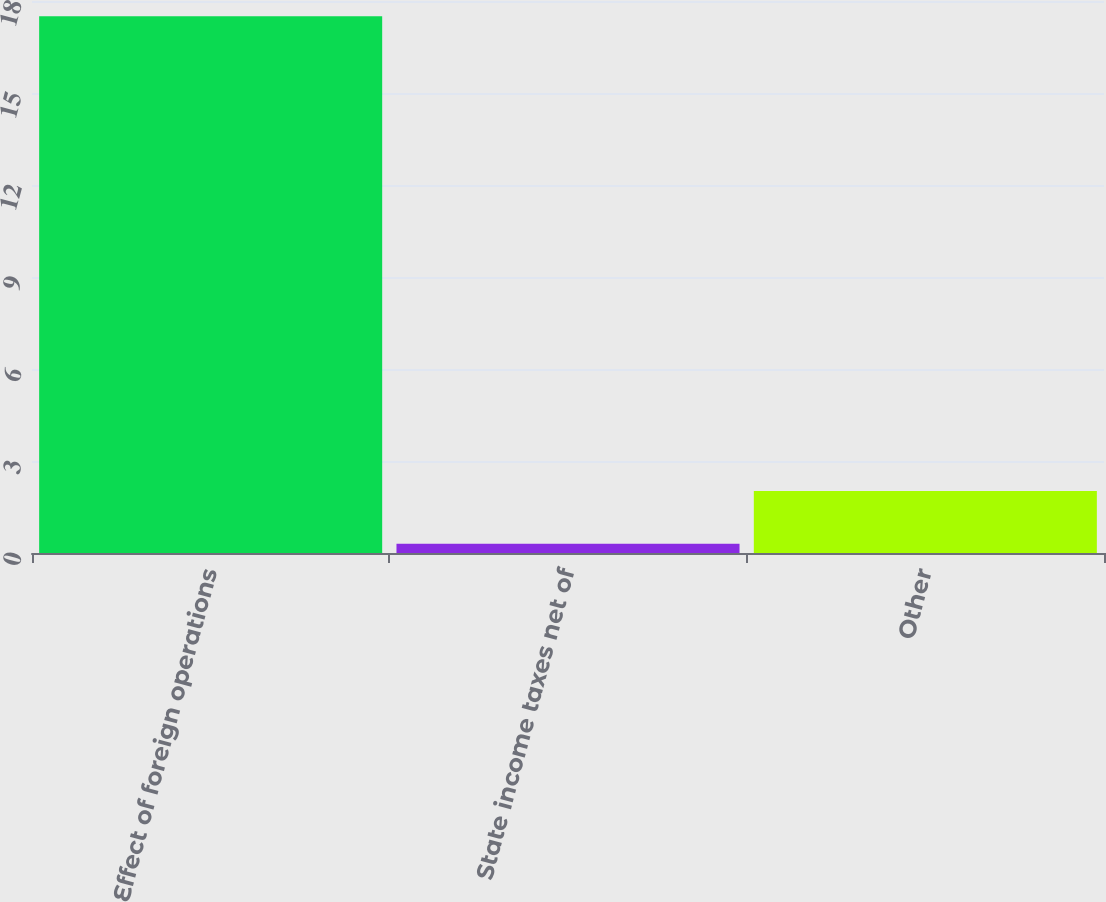Convert chart to OTSL. <chart><loc_0><loc_0><loc_500><loc_500><bar_chart><fcel>Effect of foreign operations<fcel>State income taxes net of<fcel>Other<nl><fcel>17.5<fcel>0.3<fcel>2.02<nl></chart> 